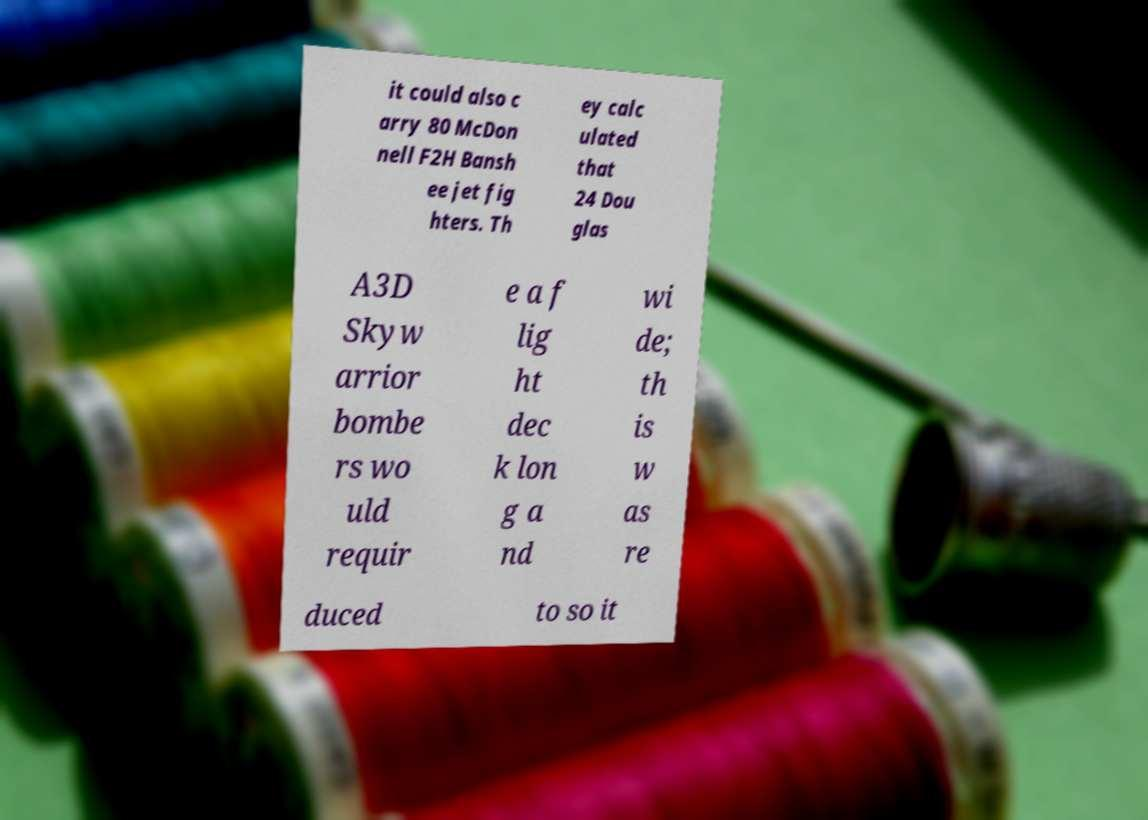Could you assist in decoding the text presented in this image and type it out clearly? it could also c arry 80 McDon nell F2H Bansh ee jet fig hters. Th ey calc ulated that 24 Dou glas A3D Skyw arrior bombe rs wo uld requir e a f lig ht dec k lon g a nd wi de; th is w as re duced to so it 